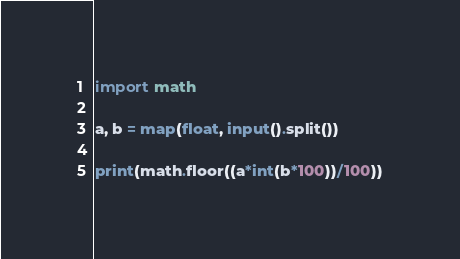Convert code to text. <code><loc_0><loc_0><loc_500><loc_500><_Python_>import math

a, b = map(float, input().split())

print(math.floor((a*int(b*100))/100))</code> 